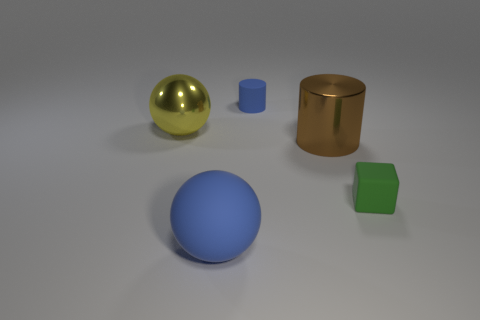Are there the same number of small blue cylinders that are behind the blue rubber cylinder and tiny objects in front of the large brown metallic object?
Your response must be concise. No. Are there any other blue cylinders made of the same material as the small blue cylinder?
Your response must be concise. No. Do the large brown cylinder and the tiny green object have the same material?
Offer a terse response. No. How many green objects are large metallic things or small metallic spheres?
Make the answer very short. 0. Is the number of rubber cylinders that are to the right of the tiny green matte cube greater than the number of matte cubes?
Ensure brevity in your answer.  No. Is there a big rubber sphere of the same color as the small cylinder?
Offer a terse response. Yes. How big is the brown shiny thing?
Offer a terse response. Large. Is the color of the rubber sphere the same as the tiny cylinder?
Give a very brief answer. Yes. What number of objects are large green shiny spheres or shiny objects that are in front of the metal sphere?
Keep it short and to the point. 1. How many blue objects are in front of the metallic object that is right of the big thing that is in front of the green object?
Your answer should be very brief. 1. 